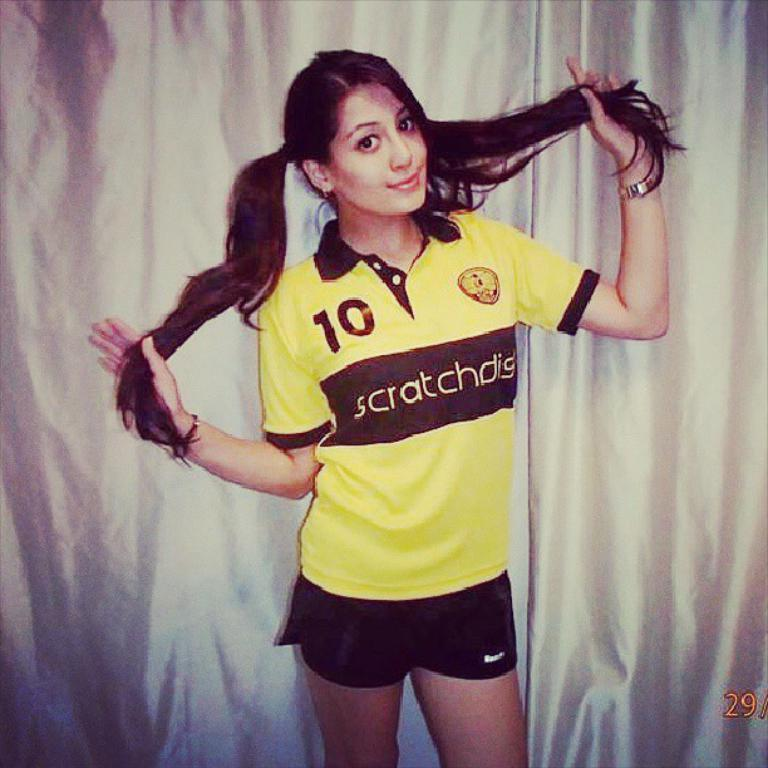<image>
Create a compact narrative representing the image presented. A young girl with long brown hair in pig tails, is posing for a photo shoot, wearing a yellow shirt with the number 10 on it. 